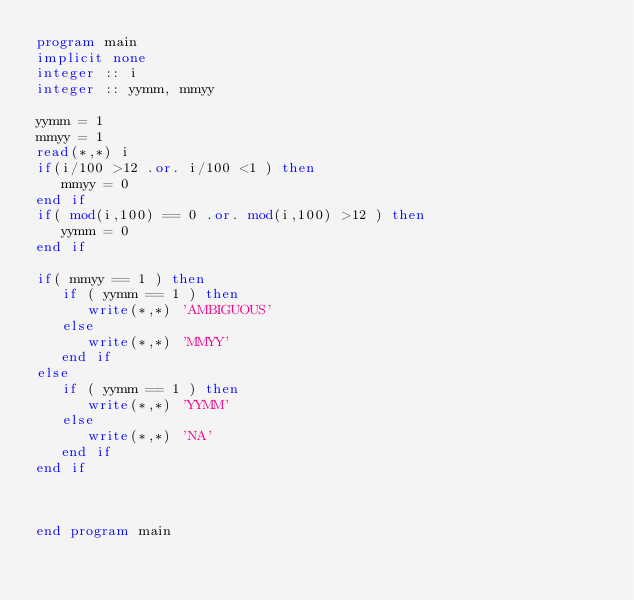Convert code to text. <code><loc_0><loc_0><loc_500><loc_500><_FORTRAN_>program main
implicit none
integer :: i
integer :: yymm, mmyy

yymm = 1
mmyy = 1
read(*,*) i
if(i/100 >12 .or. i/100 <1 ) then
   mmyy = 0
end if
if( mod(i,100) == 0 .or. mod(i,100) >12 ) then
   yymm = 0
end if

if( mmyy == 1 ) then
   if ( yymm == 1 ) then
      write(*,*) 'AMBIGUOUS'
   else
      write(*,*) 'MMYY'
   end if
else
   if ( yymm == 1 ) then
      write(*,*) 'YYMM'
   else
      write(*,*) 'NA'
   end if
end if



end program main
</code> 